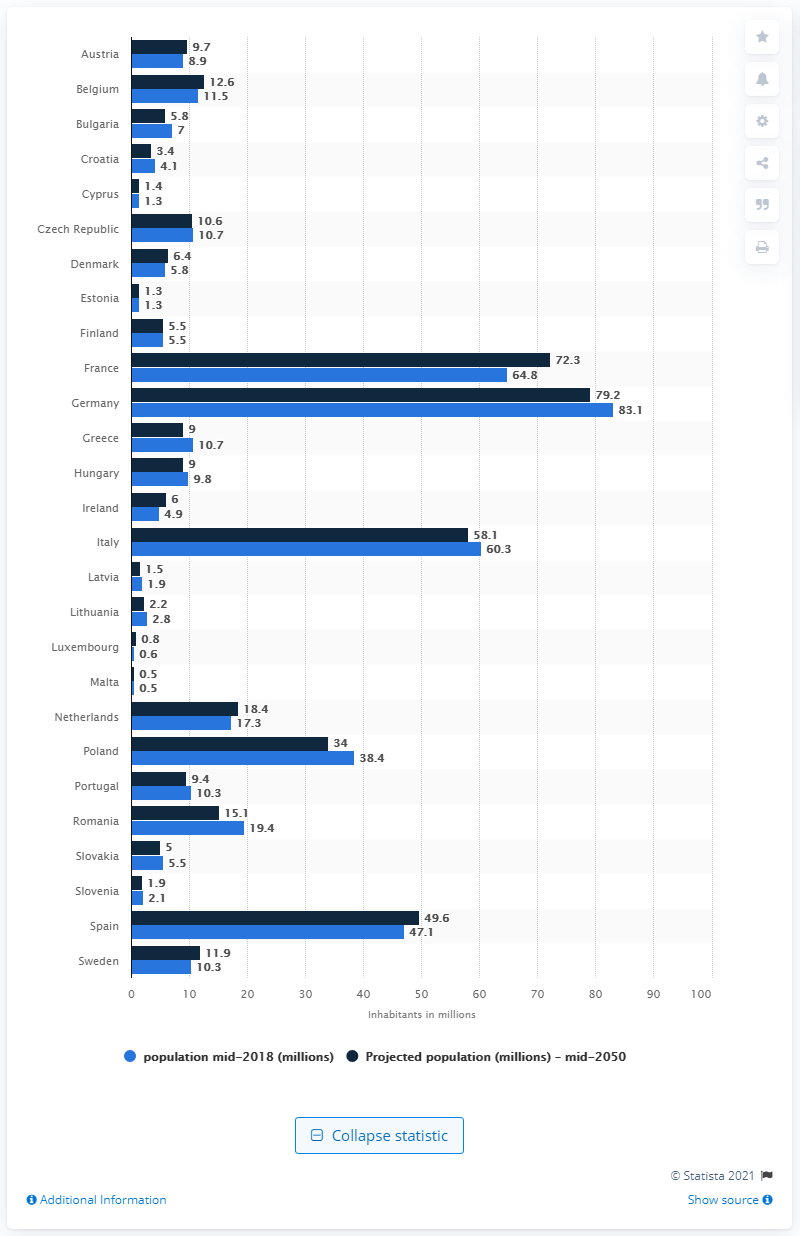Can you explain the trend in population for Eastern European countries like Poland and Romania? The image indicates a declining population trend for many Eastern European countries. For instance, Poland's population is projected to decrease from 38.4 million in mid-2018 to 34 million by mid-2050, and Romania's from 19.4 million to 15.1 million. This trend may be due to factors like emigration, lower birth rates, and aging populations. 